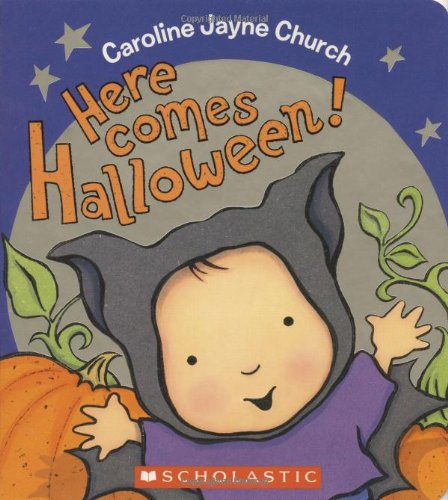Can you describe the main character shown on the cover of the book? The main character on the cover is depicted as a young child dressed in a cute bat costume, symbolizing the playful and imaginative spirit of Halloween. 